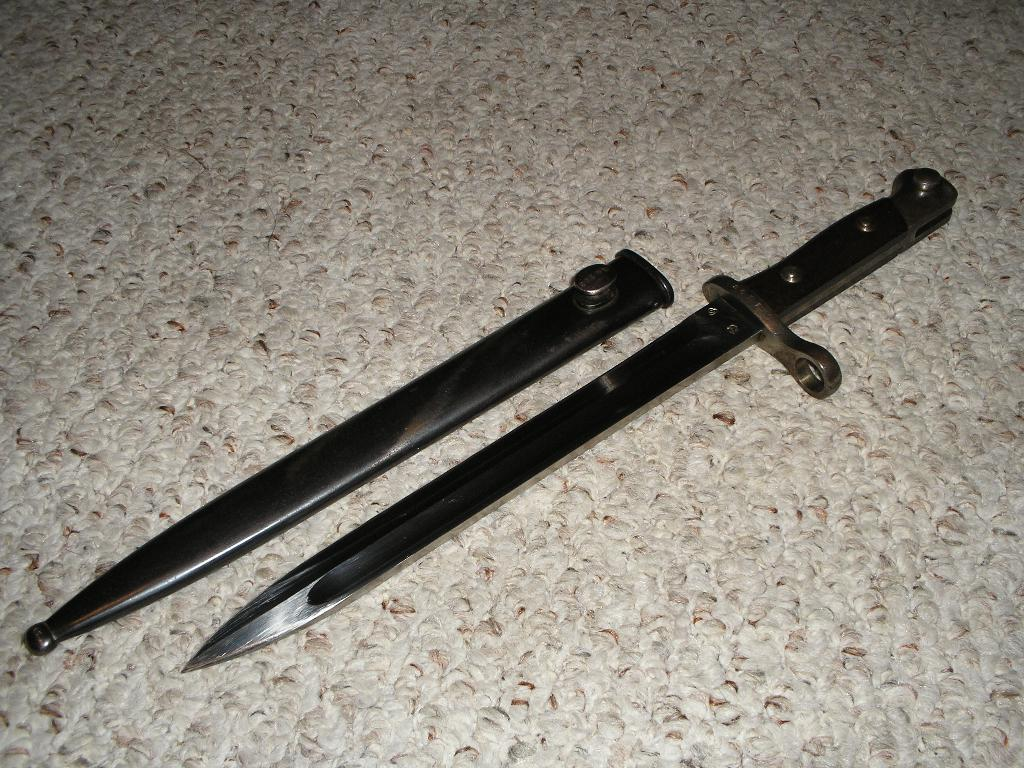What object is present in the image that can be used for cutting? There is a knife in the image. What accompanies the knife in the image? There is a knife's cover in the image. Where are the knife and knife's cover placed? The knife and knife's cover are placed on a surface. What is the color of the background in the image? The background of the image is gray in color. Can you see a crown on the knife in the image? No, there is no crown present on the knife in the image. What type of muscle is visible in the image? There are no muscles visible in the image; it features a knife and its cover placed on a surface. 